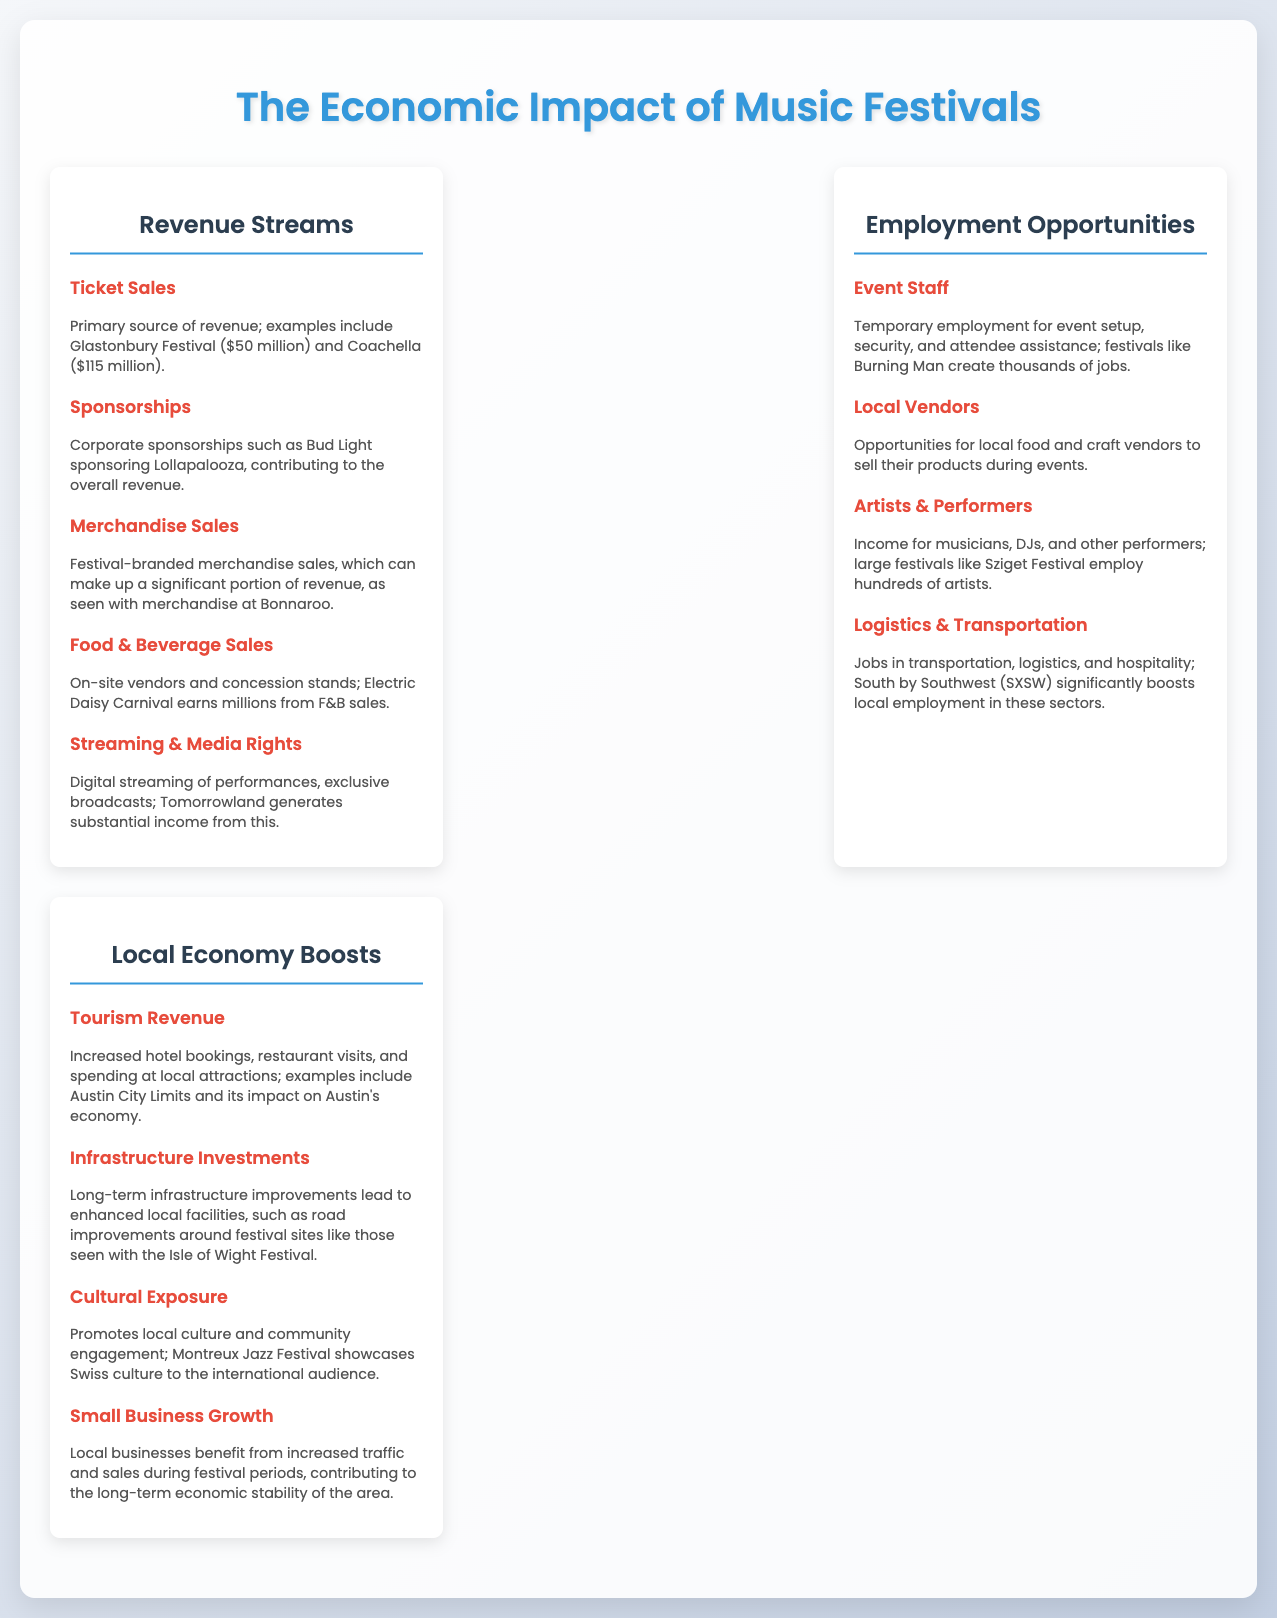what is the primary source of revenue for music festivals? The primary source of revenue is ticket sales, with notable examples like Glastonbury and Coachella.
Answer: Ticket sales how much revenue does Coachella generate from ticket sales? The document states that Coachella generates $115 million from ticket sales.
Answer: $115 million which music festival creates thousands of jobs for event staff? The document mentions Burning Man as a festival that creates thousands of jobs for event staff.
Answer: Burning Man what type of local business opportunities arise during music festivals? Local businesses benefit from opportunities for local food and craft vendors to sell their products.
Answer: Local vendors how does tourism revenue impact the local economy during festivals? Tourism revenue from festivals leads to increased hotel bookings and restaurant visits, boosting the local economy.
Answer: Increased hotel bookings and restaurant visits what is one example of a festival that boosts local employment in logistics? The document lists South by Southwest (SXSW) as an example of a festival that boosts local employment in logistics.
Answer: South by Southwest (SXSW) which revenue stream is associated with exclusive broadcasts and digital streaming? The revenue stream associated with exclusive broadcasts and digital streaming is Streaming & Media Rights.
Answer: Streaming & Media Rights how does cultural exposure benefit local communities through music festivals? Cultural exposure promotes local culture and community engagement during music festivals.
Answer: Promotes local culture and community engagement what type of infrastructure improvements may result from music festivals? The document states that long-term infrastructure improvements may include road improvements around festival sites.
Answer: Road improvements 